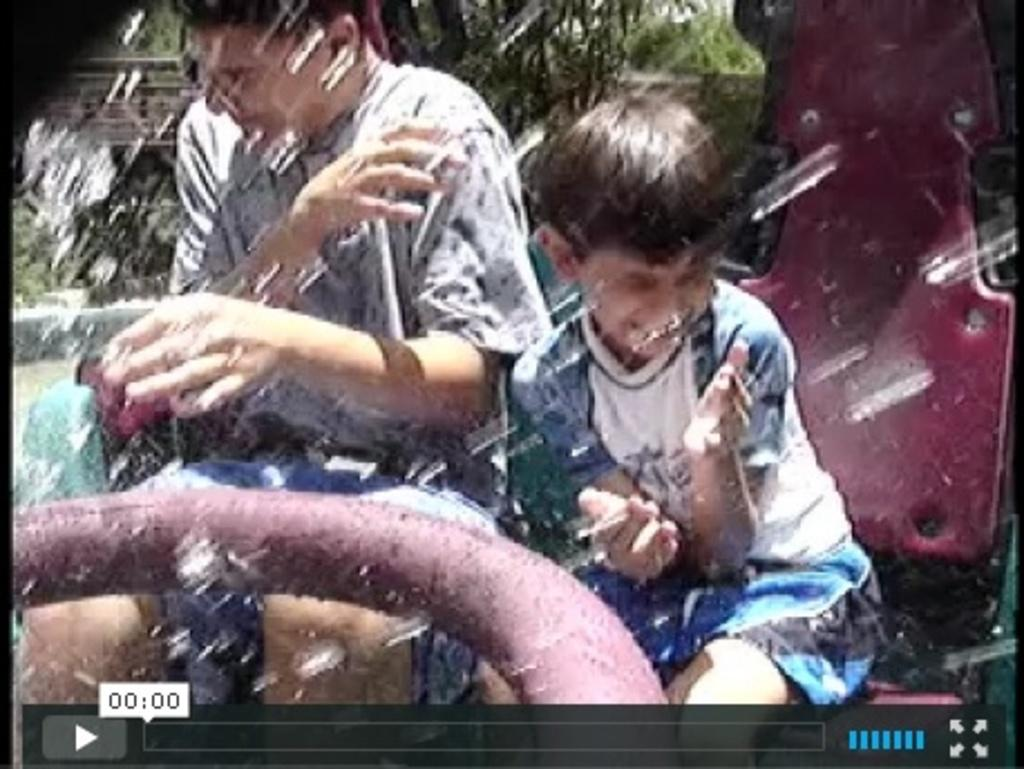What is the main subject of the image? The main subject of the image is a screen. What can be seen on the screen? The provided facts do not specify what is on the screen. What are the people in the image doing? The people in the image are sitting on a vehicle. What is visible in the background of the image? There are trees in the background of the image. What is present in front of the screen? There are water drops in front of the image. How many toes are visible on the people sitting on the vehicle in the image? There is no information about the people's toes in the provided facts, so it cannot be determined from the image. 